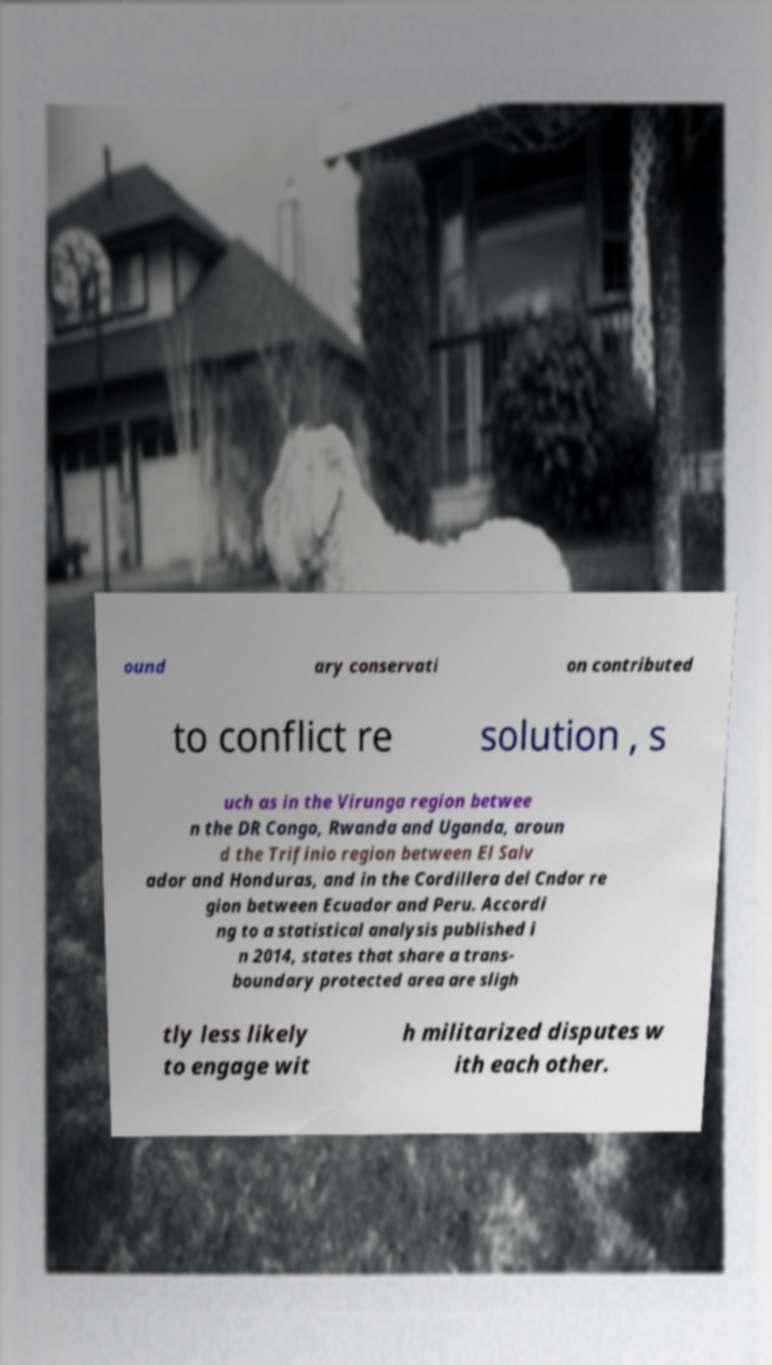Can you read and provide the text displayed in the image?This photo seems to have some interesting text. Can you extract and type it out for me? ound ary conservati on contributed to conflict re solution , s uch as in the Virunga region betwee n the DR Congo, Rwanda and Uganda, aroun d the Trifinio region between El Salv ador and Honduras, and in the Cordillera del Cndor re gion between Ecuador and Peru. Accordi ng to a statistical analysis published i n 2014, states that share a trans- boundary protected area are sligh tly less likely to engage wit h militarized disputes w ith each other. 